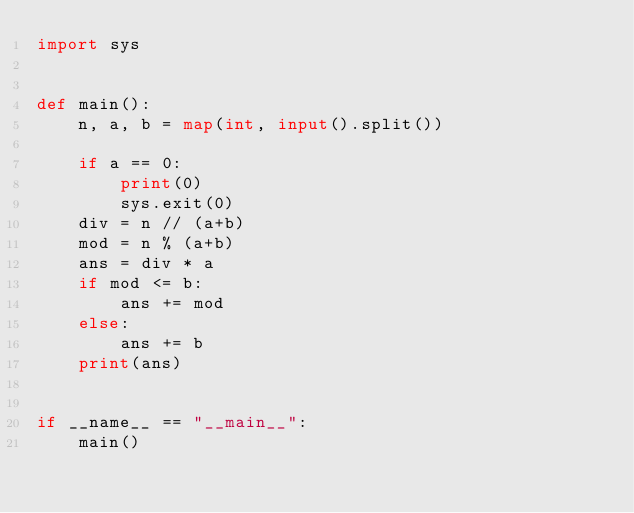Convert code to text. <code><loc_0><loc_0><loc_500><loc_500><_Python_>import sys


def main():
    n, a, b = map(int, input().split())

    if a == 0:
        print(0)
        sys.exit(0)
    div = n // (a+b)
    mod = n % (a+b)
    ans = div * a
    if mod <= b:
        ans += mod
    else:
        ans += b
    print(ans)


if __name__ == "__main__":
    main()
</code> 